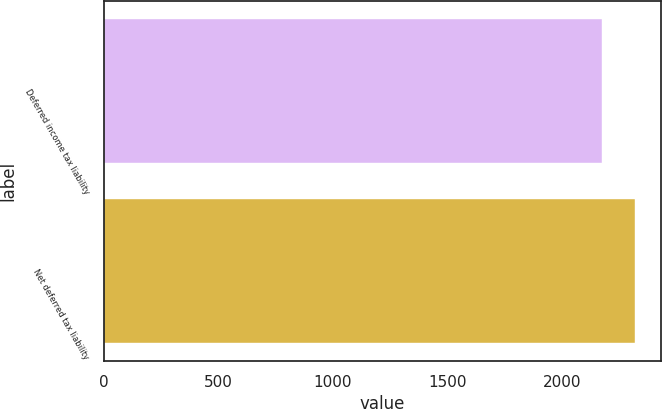Convert chart to OTSL. <chart><loc_0><loc_0><loc_500><loc_500><bar_chart><fcel>Deferred income tax liability<fcel>Net deferred tax liability<nl><fcel>2174<fcel>2316<nl></chart> 